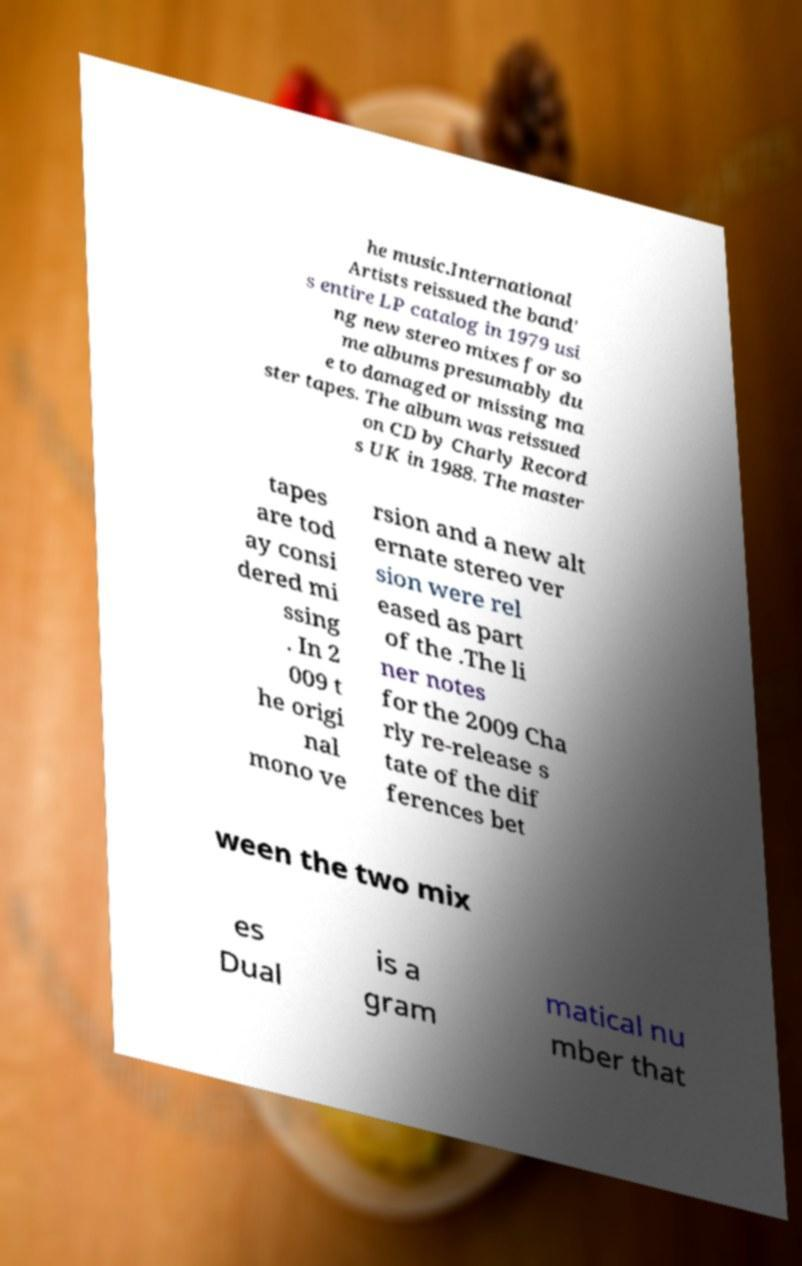Please identify and transcribe the text found in this image. he music.International Artists reissued the band' s entire LP catalog in 1979 usi ng new stereo mixes for so me albums presumably du e to damaged or missing ma ster tapes. The album was reissued on CD by Charly Record s UK in 1988. The master tapes are tod ay consi dered mi ssing . In 2 009 t he origi nal mono ve rsion and a new alt ernate stereo ver sion were rel eased as part of the .The li ner notes for the 2009 Cha rly re-release s tate of the dif ferences bet ween the two mix es Dual is a gram matical nu mber that 